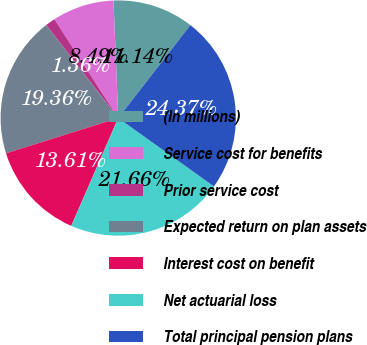Convert chart to OTSL. <chart><loc_0><loc_0><loc_500><loc_500><pie_chart><fcel>(In millions)<fcel>Service cost for benefits<fcel>Prior service cost<fcel>Expected return on plan assets<fcel>Interest cost on benefit<fcel>Net actuarial loss<fcel>Total principal pension plans<nl><fcel>11.14%<fcel>8.49%<fcel>1.36%<fcel>19.36%<fcel>13.61%<fcel>21.66%<fcel>24.37%<nl></chart> 